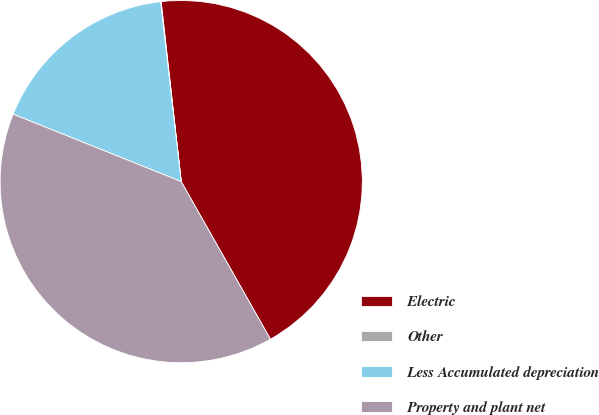<chart> <loc_0><loc_0><loc_500><loc_500><pie_chart><fcel>Electric<fcel>Other<fcel>Less Accumulated depreciation<fcel>Property and plant net<nl><fcel>43.57%<fcel>0.05%<fcel>17.11%<fcel>39.27%<nl></chart> 